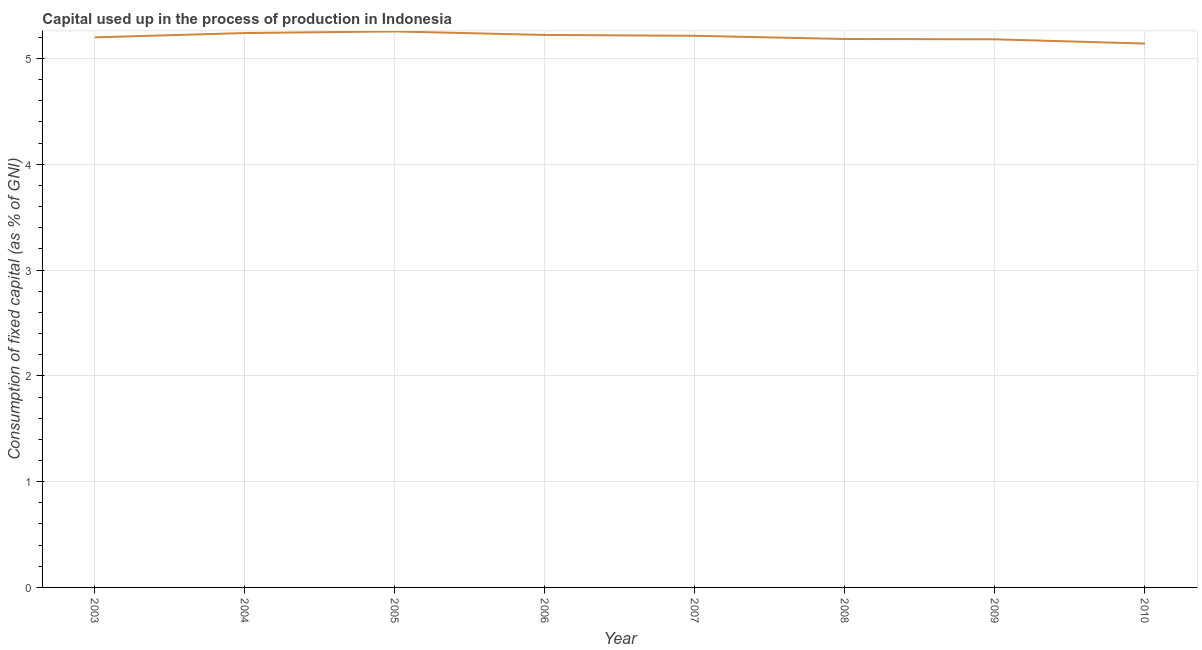What is the consumption of fixed capital in 2009?
Your answer should be very brief. 5.18. Across all years, what is the maximum consumption of fixed capital?
Provide a short and direct response. 5.26. Across all years, what is the minimum consumption of fixed capital?
Provide a succinct answer. 5.14. In which year was the consumption of fixed capital minimum?
Your answer should be very brief. 2010. What is the sum of the consumption of fixed capital?
Offer a terse response. 41.64. What is the difference between the consumption of fixed capital in 2005 and 2008?
Ensure brevity in your answer.  0.07. What is the average consumption of fixed capital per year?
Ensure brevity in your answer.  5.2. What is the median consumption of fixed capital?
Make the answer very short. 5.21. Do a majority of the years between 2006 and 2004 (inclusive) have consumption of fixed capital greater than 4 %?
Ensure brevity in your answer.  No. What is the ratio of the consumption of fixed capital in 2005 to that in 2006?
Offer a very short reply. 1.01. Is the consumption of fixed capital in 2004 less than that in 2009?
Your response must be concise. No. What is the difference between the highest and the second highest consumption of fixed capital?
Your answer should be compact. 0.02. Is the sum of the consumption of fixed capital in 2003 and 2008 greater than the maximum consumption of fixed capital across all years?
Your response must be concise. Yes. What is the difference between the highest and the lowest consumption of fixed capital?
Provide a succinct answer. 0.11. In how many years, is the consumption of fixed capital greater than the average consumption of fixed capital taken over all years?
Make the answer very short. 4. Does the consumption of fixed capital monotonically increase over the years?
Make the answer very short. No. How many years are there in the graph?
Your answer should be compact. 8. What is the difference between two consecutive major ticks on the Y-axis?
Ensure brevity in your answer.  1. Does the graph contain grids?
Your answer should be very brief. Yes. What is the title of the graph?
Provide a succinct answer. Capital used up in the process of production in Indonesia. What is the label or title of the X-axis?
Keep it short and to the point. Year. What is the label or title of the Y-axis?
Your response must be concise. Consumption of fixed capital (as % of GNI). What is the Consumption of fixed capital (as % of GNI) in 2003?
Make the answer very short. 5.2. What is the Consumption of fixed capital (as % of GNI) in 2004?
Offer a very short reply. 5.24. What is the Consumption of fixed capital (as % of GNI) in 2005?
Provide a short and direct response. 5.26. What is the Consumption of fixed capital (as % of GNI) in 2006?
Provide a short and direct response. 5.22. What is the Consumption of fixed capital (as % of GNI) of 2007?
Provide a succinct answer. 5.21. What is the Consumption of fixed capital (as % of GNI) in 2008?
Offer a terse response. 5.18. What is the Consumption of fixed capital (as % of GNI) in 2009?
Offer a terse response. 5.18. What is the Consumption of fixed capital (as % of GNI) of 2010?
Your answer should be compact. 5.14. What is the difference between the Consumption of fixed capital (as % of GNI) in 2003 and 2004?
Offer a terse response. -0.04. What is the difference between the Consumption of fixed capital (as % of GNI) in 2003 and 2005?
Your answer should be compact. -0.06. What is the difference between the Consumption of fixed capital (as % of GNI) in 2003 and 2006?
Ensure brevity in your answer.  -0.02. What is the difference between the Consumption of fixed capital (as % of GNI) in 2003 and 2007?
Make the answer very short. -0.01. What is the difference between the Consumption of fixed capital (as % of GNI) in 2003 and 2008?
Your answer should be compact. 0.02. What is the difference between the Consumption of fixed capital (as % of GNI) in 2003 and 2009?
Give a very brief answer. 0.02. What is the difference between the Consumption of fixed capital (as % of GNI) in 2003 and 2010?
Give a very brief answer. 0.06. What is the difference between the Consumption of fixed capital (as % of GNI) in 2004 and 2005?
Keep it short and to the point. -0.02. What is the difference between the Consumption of fixed capital (as % of GNI) in 2004 and 2006?
Ensure brevity in your answer.  0.02. What is the difference between the Consumption of fixed capital (as % of GNI) in 2004 and 2007?
Keep it short and to the point. 0.03. What is the difference between the Consumption of fixed capital (as % of GNI) in 2004 and 2008?
Ensure brevity in your answer.  0.06. What is the difference between the Consumption of fixed capital (as % of GNI) in 2004 and 2009?
Your answer should be very brief. 0.06. What is the difference between the Consumption of fixed capital (as % of GNI) in 2004 and 2010?
Ensure brevity in your answer.  0.1. What is the difference between the Consumption of fixed capital (as % of GNI) in 2005 and 2006?
Provide a short and direct response. 0.03. What is the difference between the Consumption of fixed capital (as % of GNI) in 2005 and 2007?
Ensure brevity in your answer.  0.04. What is the difference between the Consumption of fixed capital (as % of GNI) in 2005 and 2008?
Make the answer very short. 0.07. What is the difference between the Consumption of fixed capital (as % of GNI) in 2005 and 2009?
Give a very brief answer. 0.07. What is the difference between the Consumption of fixed capital (as % of GNI) in 2005 and 2010?
Ensure brevity in your answer.  0.11. What is the difference between the Consumption of fixed capital (as % of GNI) in 2006 and 2007?
Offer a terse response. 0.01. What is the difference between the Consumption of fixed capital (as % of GNI) in 2006 and 2008?
Give a very brief answer. 0.04. What is the difference between the Consumption of fixed capital (as % of GNI) in 2006 and 2009?
Provide a succinct answer. 0.04. What is the difference between the Consumption of fixed capital (as % of GNI) in 2006 and 2010?
Give a very brief answer. 0.08. What is the difference between the Consumption of fixed capital (as % of GNI) in 2007 and 2008?
Offer a very short reply. 0.03. What is the difference between the Consumption of fixed capital (as % of GNI) in 2007 and 2009?
Your answer should be compact. 0.03. What is the difference between the Consumption of fixed capital (as % of GNI) in 2007 and 2010?
Keep it short and to the point. 0.07. What is the difference between the Consumption of fixed capital (as % of GNI) in 2008 and 2009?
Give a very brief answer. 0. What is the difference between the Consumption of fixed capital (as % of GNI) in 2008 and 2010?
Provide a short and direct response. 0.04. What is the difference between the Consumption of fixed capital (as % of GNI) in 2009 and 2010?
Provide a short and direct response. 0.04. What is the ratio of the Consumption of fixed capital (as % of GNI) in 2003 to that in 2004?
Provide a succinct answer. 0.99. What is the ratio of the Consumption of fixed capital (as % of GNI) in 2003 to that in 2007?
Offer a very short reply. 1. What is the ratio of the Consumption of fixed capital (as % of GNI) in 2003 to that in 2008?
Your answer should be compact. 1. What is the ratio of the Consumption of fixed capital (as % of GNI) in 2003 to that in 2010?
Offer a terse response. 1.01. What is the ratio of the Consumption of fixed capital (as % of GNI) in 2004 to that in 2007?
Provide a short and direct response. 1. What is the ratio of the Consumption of fixed capital (as % of GNI) in 2004 to that in 2010?
Provide a short and direct response. 1.02. What is the ratio of the Consumption of fixed capital (as % of GNI) in 2005 to that in 2006?
Provide a succinct answer. 1.01. What is the ratio of the Consumption of fixed capital (as % of GNI) in 2005 to that in 2007?
Keep it short and to the point. 1.01. What is the ratio of the Consumption of fixed capital (as % of GNI) in 2005 to that in 2008?
Provide a succinct answer. 1.01. What is the ratio of the Consumption of fixed capital (as % of GNI) in 2005 to that in 2009?
Ensure brevity in your answer.  1.01. What is the ratio of the Consumption of fixed capital (as % of GNI) in 2005 to that in 2010?
Offer a terse response. 1.02. What is the ratio of the Consumption of fixed capital (as % of GNI) in 2006 to that in 2007?
Your response must be concise. 1. What is the ratio of the Consumption of fixed capital (as % of GNI) in 2006 to that in 2008?
Offer a terse response. 1.01. What is the ratio of the Consumption of fixed capital (as % of GNI) in 2006 to that in 2009?
Your answer should be compact. 1.01. What is the ratio of the Consumption of fixed capital (as % of GNI) in 2007 to that in 2008?
Provide a short and direct response. 1.01. What is the ratio of the Consumption of fixed capital (as % of GNI) in 2007 to that in 2009?
Provide a succinct answer. 1.01. 